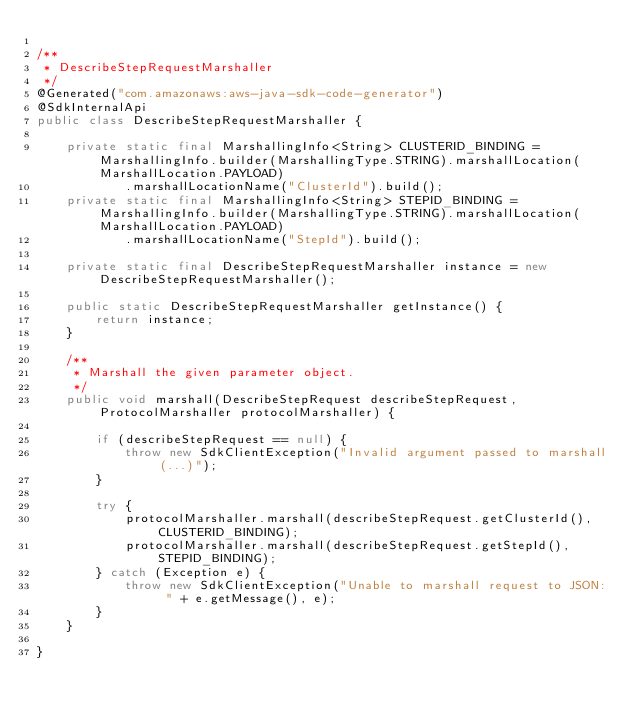Convert code to text. <code><loc_0><loc_0><loc_500><loc_500><_Java_>
/**
 * DescribeStepRequestMarshaller
 */
@Generated("com.amazonaws:aws-java-sdk-code-generator")
@SdkInternalApi
public class DescribeStepRequestMarshaller {

    private static final MarshallingInfo<String> CLUSTERID_BINDING = MarshallingInfo.builder(MarshallingType.STRING).marshallLocation(MarshallLocation.PAYLOAD)
            .marshallLocationName("ClusterId").build();
    private static final MarshallingInfo<String> STEPID_BINDING = MarshallingInfo.builder(MarshallingType.STRING).marshallLocation(MarshallLocation.PAYLOAD)
            .marshallLocationName("StepId").build();

    private static final DescribeStepRequestMarshaller instance = new DescribeStepRequestMarshaller();

    public static DescribeStepRequestMarshaller getInstance() {
        return instance;
    }

    /**
     * Marshall the given parameter object.
     */
    public void marshall(DescribeStepRequest describeStepRequest, ProtocolMarshaller protocolMarshaller) {

        if (describeStepRequest == null) {
            throw new SdkClientException("Invalid argument passed to marshall(...)");
        }

        try {
            protocolMarshaller.marshall(describeStepRequest.getClusterId(), CLUSTERID_BINDING);
            protocolMarshaller.marshall(describeStepRequest.getStepId(), STEPID_BINDING);
        } catch (Exception e) {
            throw new SdkClientException("Unable to marshall request to JSON: " + e.getMessage(), e);
        }
    }

}
</code> 